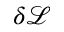Convert formula to latex. <formula><loc_0><loc_0><loc_500><loc_500>\delta \mathcal { L }</formula> 